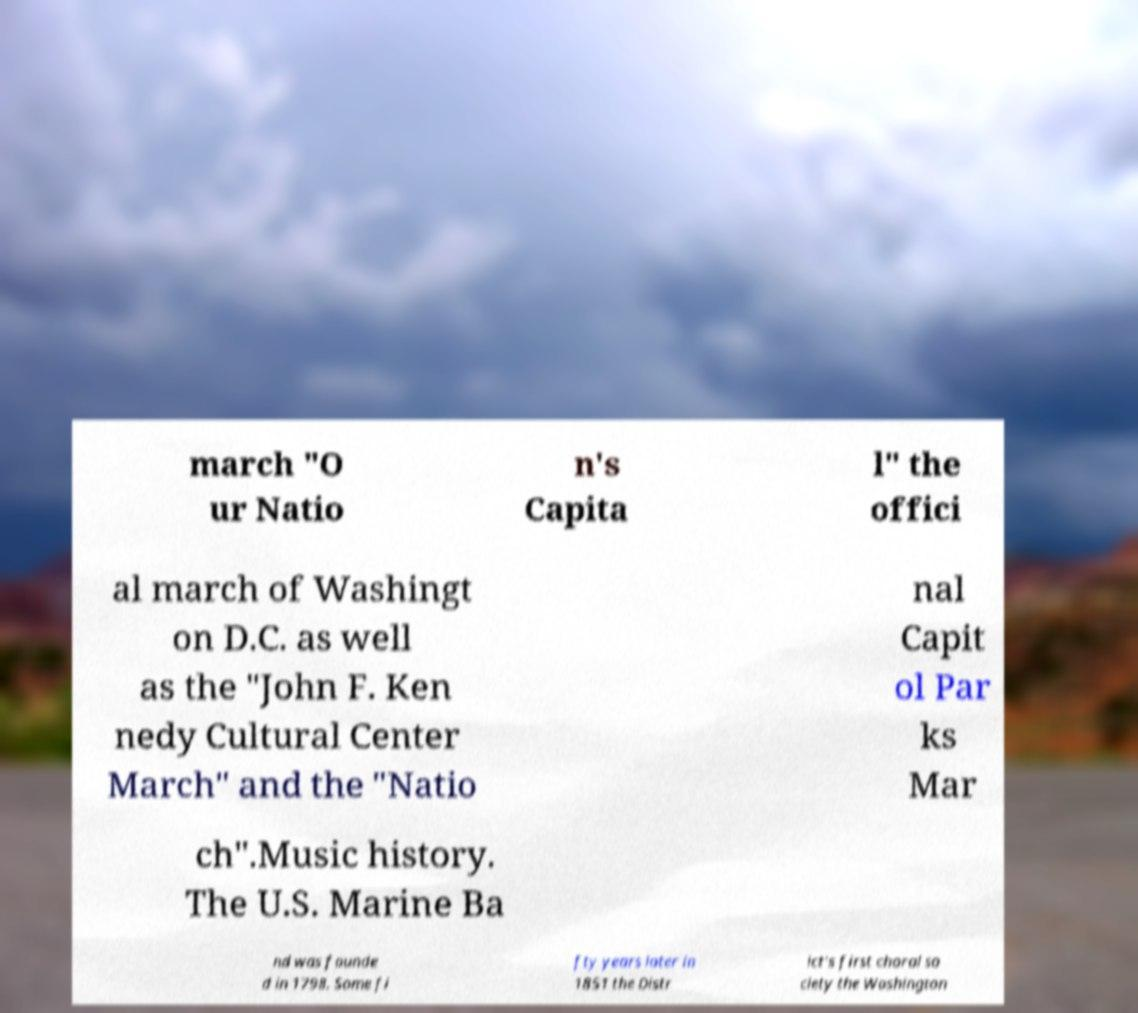Could you extract and type out the text from this image? march "O ur Natio n's Capita l" the offici al march of Washingt on D.C. as well as the "John F. Ken nedy Cultural Center March" and the "Natio nal Capit ol Par ks Mar ch".Music history. The U.S. Marine Ba nd was founde d in 1798. Some fi fty years later in 1851 the Distr ict's first choral so ciety the Washington 